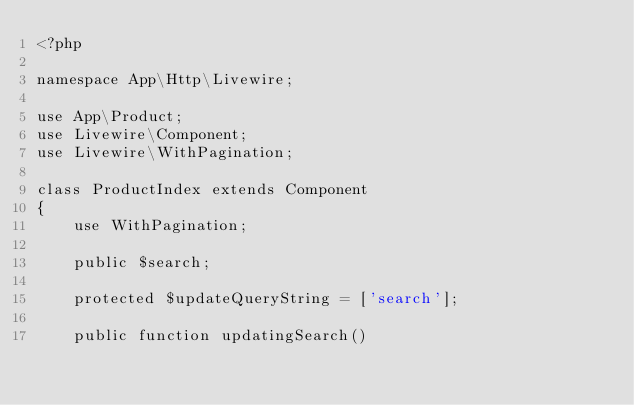Convert code to text. <code><loc_0><loc_0><loc_500><loc_500><_PHP_><?php

namespace App\Http\Livewire;

use App\Product;
use Livewire\Component;
use Livewire\WithPagination;

class ProductIndex extends Component
{
    use WithPagination;

    public $search;

    protected $updateQueryString = ['search'];

    public function updatingSearch()</code> 